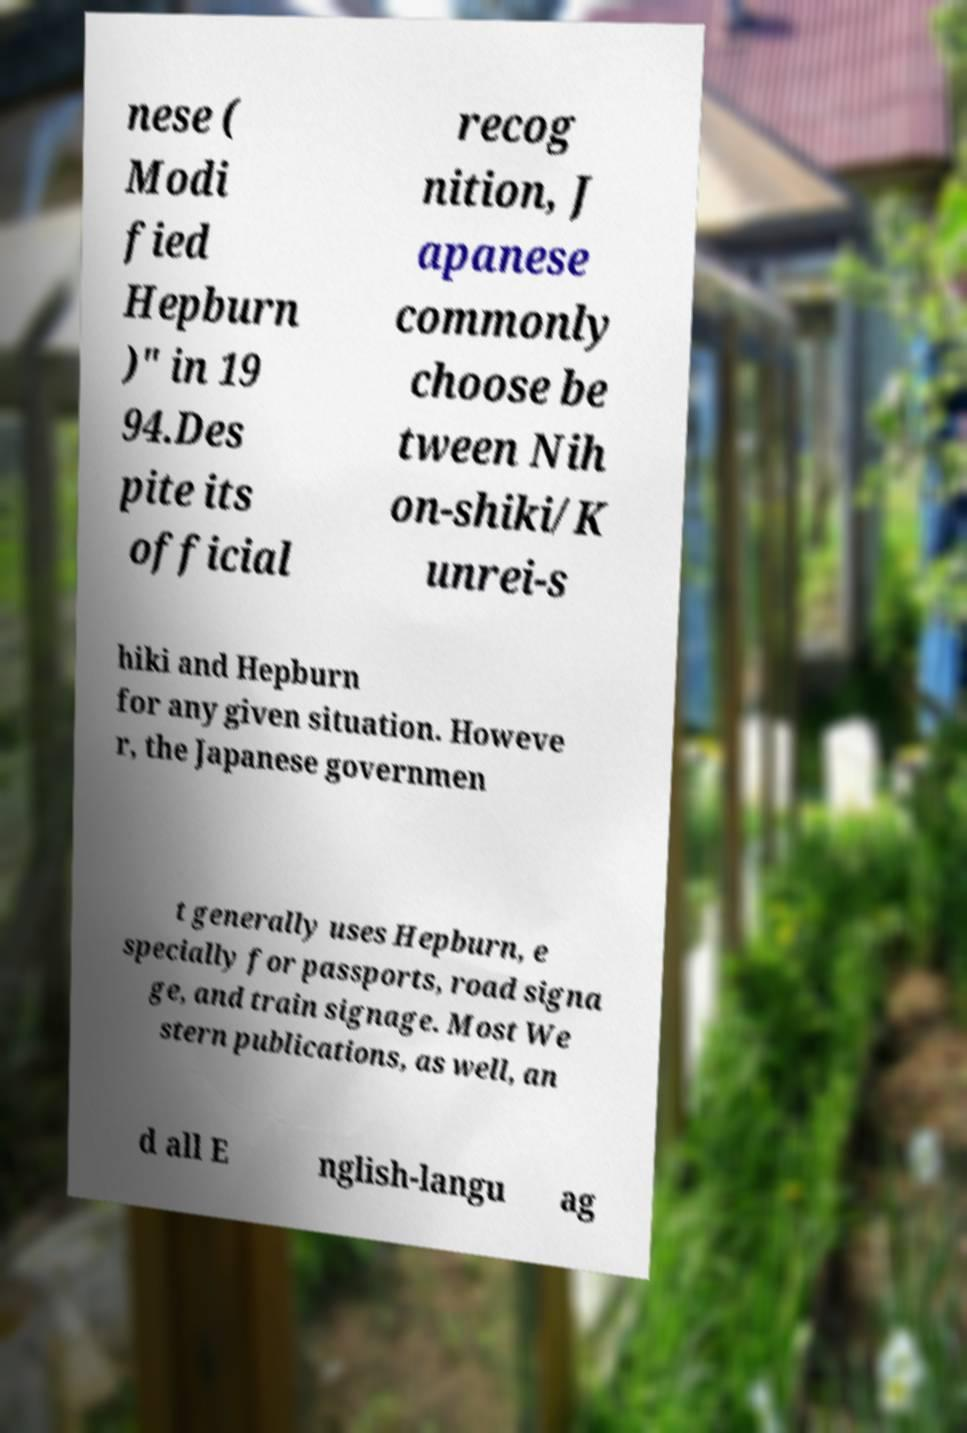Please read and relay the text visible in this image. What does it say? nese ( Modi fied Hepburn )" in 19 94.Des pite its official recog nition, J apanese commonly choose be tween Nih on-shiki/K unrei-s hiki and Hepburn for any given situation. Howeve r, the Japanese governmen t generally uses Hepburn, e specially for passports, road signa ge, and train signage. Most We stern publications, as well, an d all E nglish-langu ag 